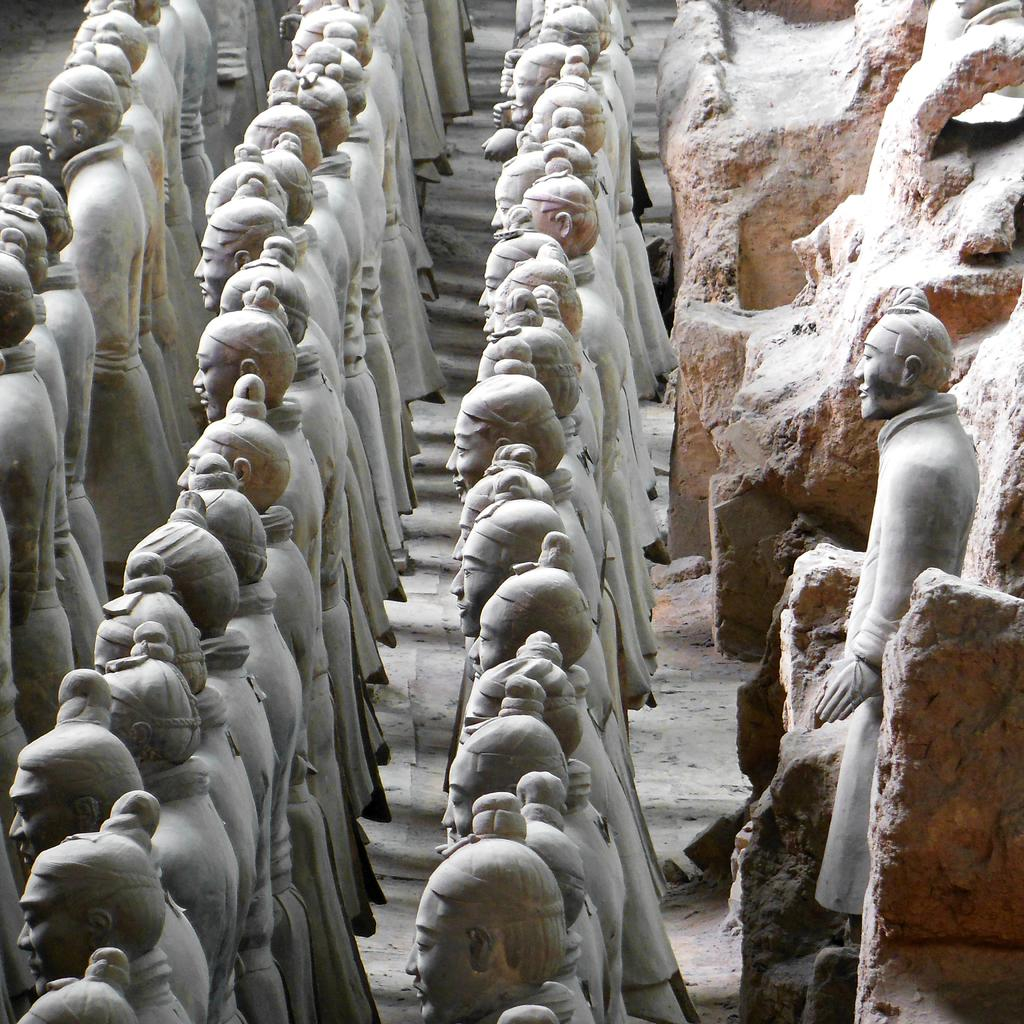What can be seen on the ground in the image? There are many sculptures on the ground in the image. What is located to the right in the image? There are rocks to the right in the image. What type of unit is present in the image? There is no unit present in the image; it features sculptures on the ground and rocks to the right. Can you tell me where the nearest hospital is in the image? There is no hospital present in the image, as it focuses on sculptures and rocks. 